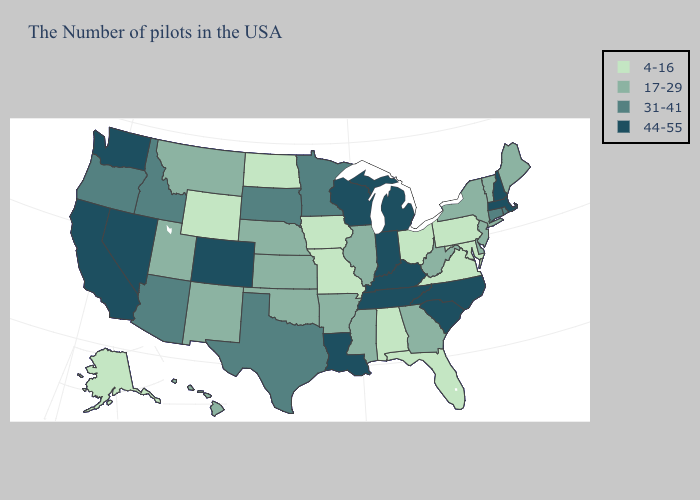Name the states that have a value in the range 4-16?
Keep it brief. Maryland, Pennsylvania, Virginia, Ohio, Florida, Alabama, Missouri, Iowa, North Dakota, Wyoming, Alaska. What is the lowest value in the MidWest?
Keep it brief. 4-16. Does Oklahoma have the same value as California?
Be succinct. No. Name the states that have a value in the range 44-55?
Write a very short answer. Massachusetts, New Hampshire, North Carolina, South Carolina, Michigan, Kentucky, Indiana, Tennessee, Wisconsin, Louisiana, Colorado, Nevada, California, Washington. Does Arkansas have the highest value in the USA?
Keep it brief. No. Which states have the highest value in the USA?
Answer briefly. Massachusetts, New Hampshire, North Carolina, South Carolina, Michigan, Kentucky, Indiana, Tennessee, Wisconsin, Louisiana, Colorado, Nevada, California, Washington. Name the states that have a value in the range 31-41?
Quick response, please. Rhode Island, Connecticut, Minnesota, Texas, South Dakota, Arizona, Idaho, Oregon. What is the lowest value in the USA?
Short answer required. 4-16. What is the value of New Jersey?
Quick response, please. 17-29. Name the states that have a value in the range 44-55?
Quick response, please. Massachusetts, New Hampshire, North Carolina, South Carolina, Michigan, Kentucky, Indiana, Tennessee, Wisconsin, Louisiana, Colorado, Nevada, California, Washington. What is the value of Iowa?
Answer briefly. 4-16. Which states have the lowest value in the Northeast?
Keep it brief. Pennsylvania. Does Colorado have the highest value in the West?
Give a very brief answer. Yes. What is the value of California?
Short answer required. 44-55. What is the highest value in states that border Maine?
Short answer required. 44-55. 